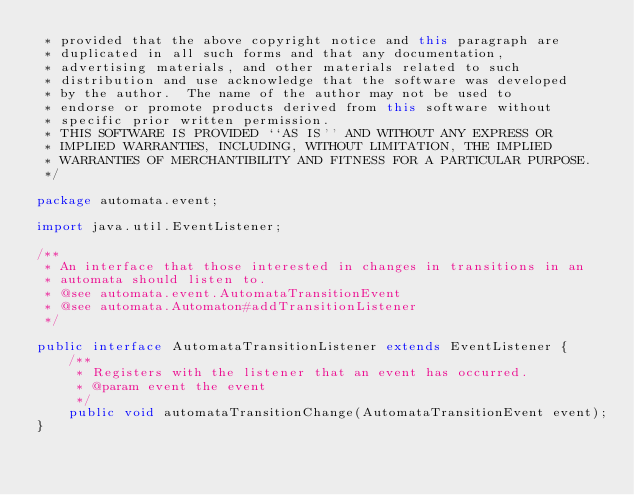<code> <loc_0><loc_0><loc_500><loc_500><_Java_> * provided that the above copyright notice and this paragraph are
 * duplicated in all such forms and that any documentation,
 * advertising materials, and other materials related to such
 * distribution and use acknowledge that the software was developed
 * by the author.  The name of the author may not be used to
 * endorse or promote products derived from this software without
 * specific prior written permission.
 * THIS SOFTWARE IS PROVIDED ``AS IS'' AND WITHOUT ANY EXPRESS OR
 * IMPLIED WARRANTIES, INCLUDING, WITHOUT LIMITATION, THE IMPLIED
 * WARRANTIES OF MERCHANTIBILITY AND FITNESS FOR A PARTICULAR PURPOSE.
 */
 
package automata.event;

import java.util.EventListener;

/**
 * An interface that those interested in changes in transitions in an
 * automata should listen to.
 * @see automata.event.AutomataTransitionEvent
 * @see automata.Automaton#addTransitionListener
 */

public interface AutomataTransitionListener extends EventListener {
    /**
     * Registers with the listener that an event has occurred.
     * @param event the event
     */
    public void automataTransitionChange(AutomataTransitionEvent event);
}
</code> 